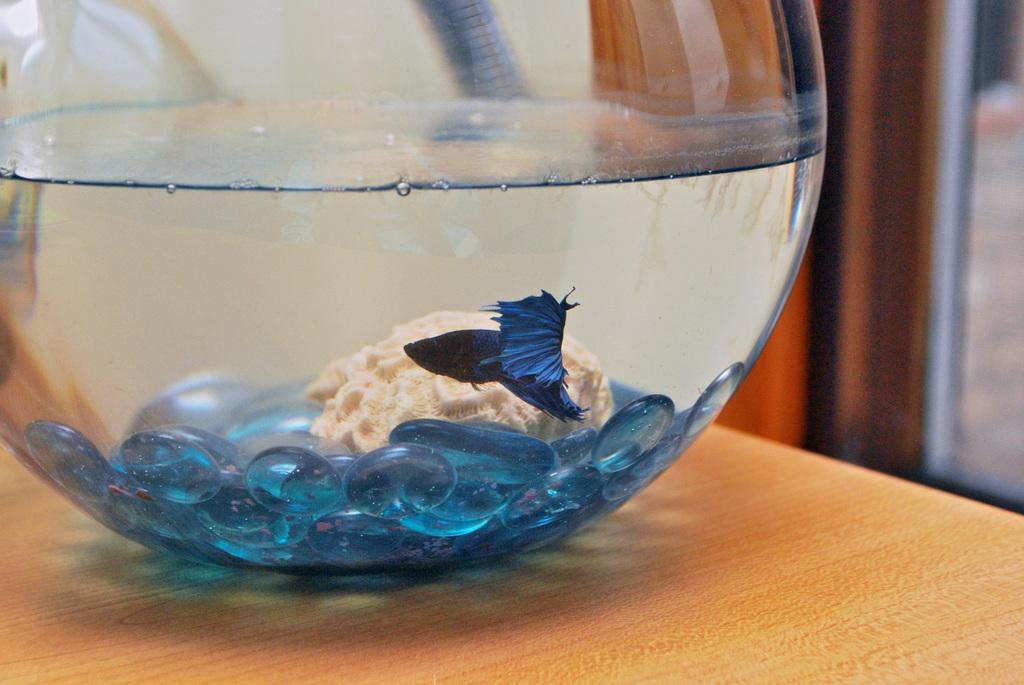Can you describe this image briefly? There is a bowl with water. Inside that there is a fighter fish, blue color stones and some other thing. And it is on a wooden surface. 